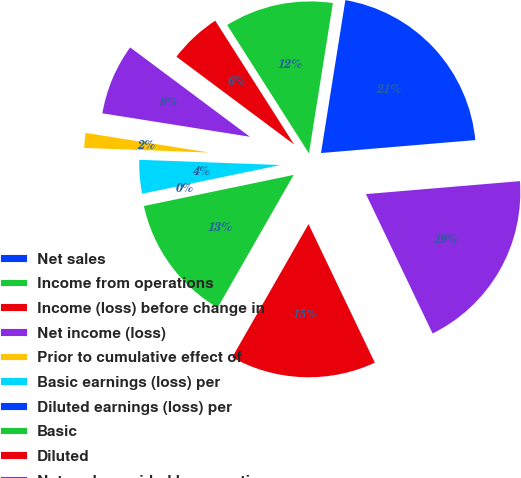Convert chart. <chart><loc_0><loc_0><loc_500><loc_500><pie_chart><fcel>Net sales<fcel>Income from operations<fcel>Income (loss) before change in<fcel>Net income (loss)<fcel>Prior to cumulative effect of<fcel>Basic earnings (loss) per<fcel>Diluted earnings (loss) per<fcel>Basic<fcel>Diluted<fcel>Net cash provided by operating<nl><fcel>21.15%<fcel>11.54%<fcel>5.77%<fcel>7.69%<fcel>1.92%<fcel>3.85%<fcel>0.0%<fcel>13.46%<fcel>15.38%<fcel>19.23%<nl></chart> 